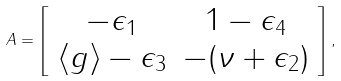<formula> <loc_0><loc_0><loc_500><loc_500>\ A = \left [ \begin{array} { c c } - \epsilon _ { 1 } & 1 - \epsilon _ { 4 } \\ \left \langle g \right \rangle - \epsilon _ { 3 } & - ( \nu + \epsilon _ { 2 } ) \end{array} \right ] ,</formula> 